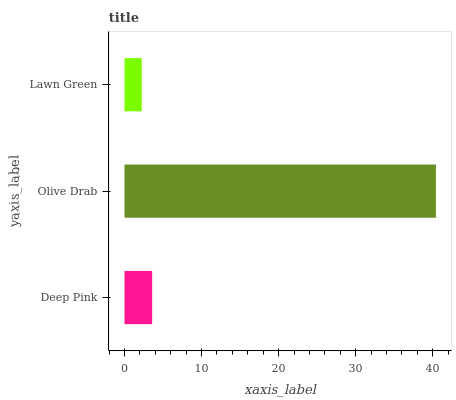Is Lawn Green the minimum?
Answer yes or no. Yes. Is Olive Drab the maximum?
Answer yes or no. Yes. Is Olive Drab the minimum?
Answer yes or no. No. Is Lawn Green the maximum?
Answer yes or no. No. Is Olive Drab greater than Lawn Green?
Answer yes or no. Yes. Is Lawn Green less than Olive Drab?
Answer yes or no. Yes. Is Lawn Green greater than Olive Drab?
Answer yes or no. No. Is Olive Drab less than Lawn Green?
Answer yes or no. No. Is Deep Pink the high median?
Answer yes or no. Yes. Is Deep Pink the low median?
Answer yes or no. Yes. Is Olive Drab the high median?
Answer yes or no. No. Is Olive Drab the low median?
Answer yes or no. No. 